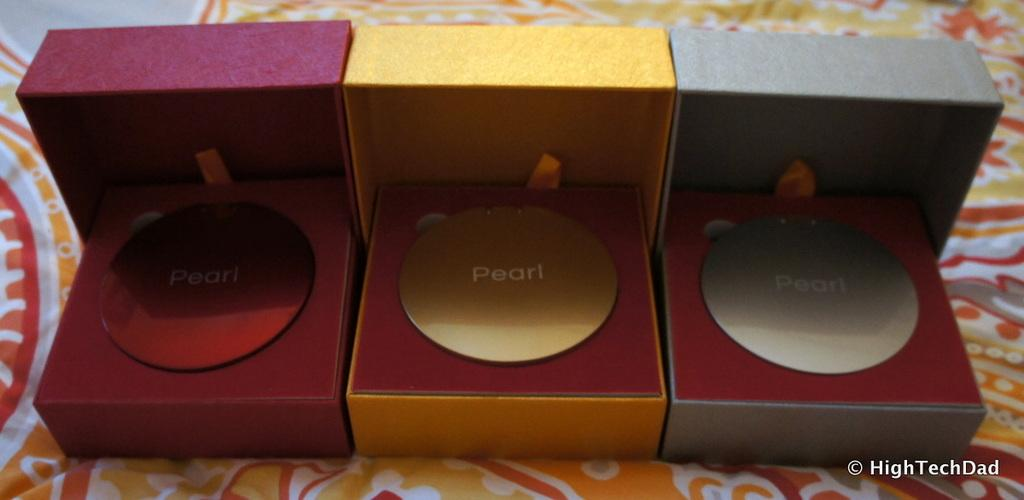Provide a one-sentence caption for the provided image. Three boxes with a pearl wrote in the inside. 